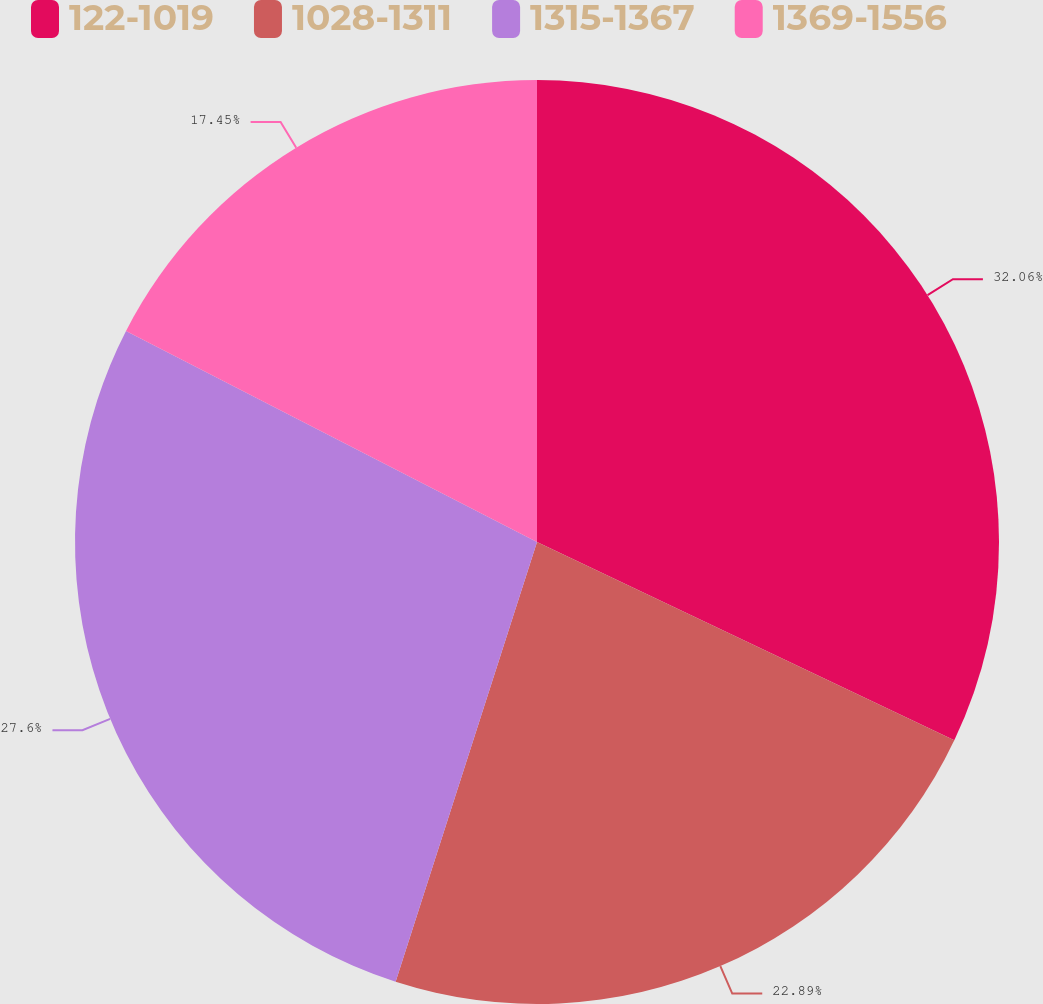Convert chart to OTSL. <chart><loc_0><loc_0><loc_500><loc_500><pie_chart><fcel>122-1019<fcel>1028-1311<fcel>1315-1367<fcel>1369-1556<nl><fcel>32.06%<fcel>22.89%<fcel>27.6%<fcel>17.45%<nl></chart> 